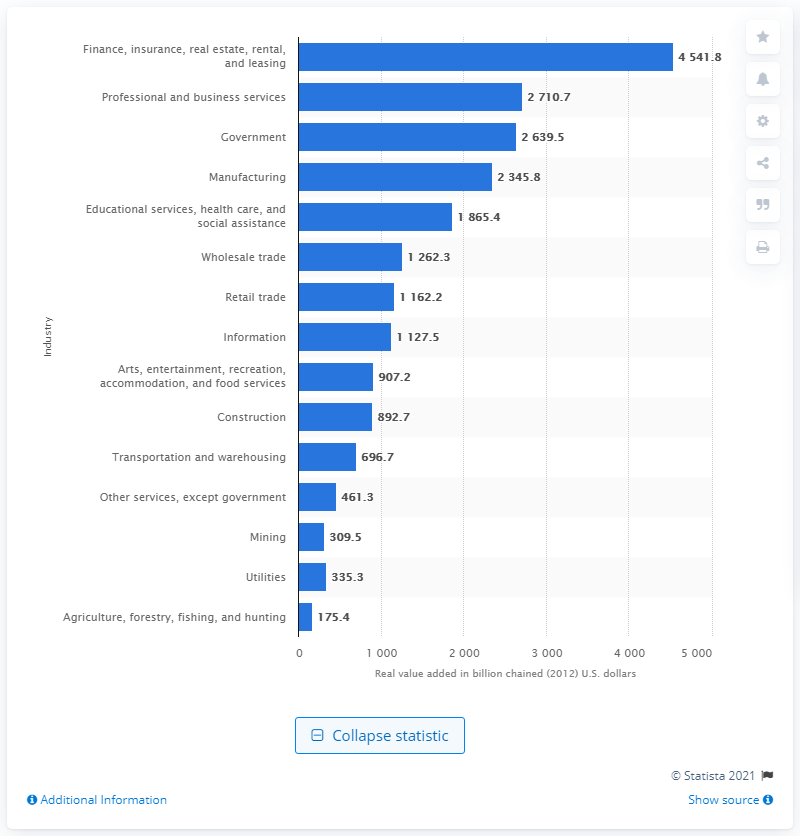Outline some significant characteristics in this image. In 2019, the mining industry contributed $309.5 billion to the overall real gross domestic product (GDP) of the United States. 